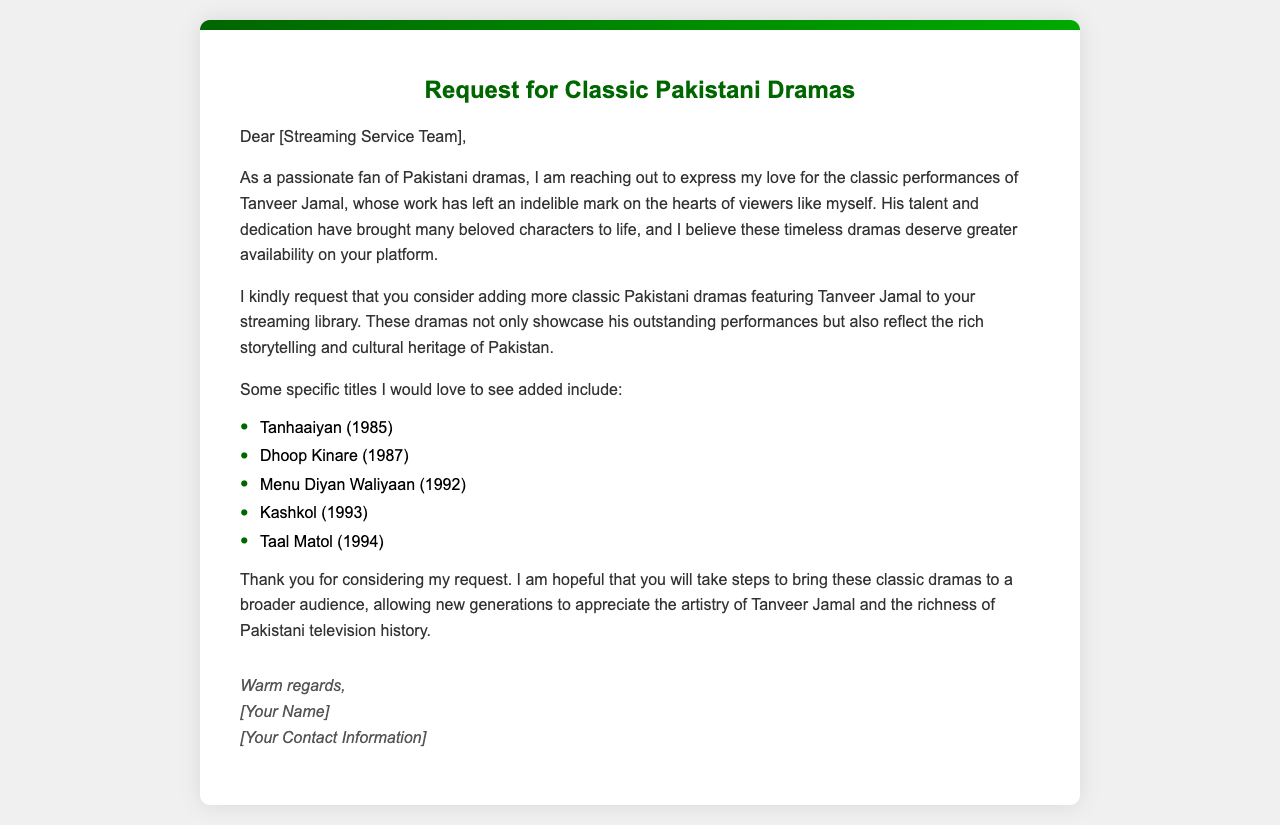What is the title of the letter? The title of the letter is prominently displayed at the top of the document, indicating the main purpose of the communication.
Answer: Request for Classic Pakistani Dramas Who is the letter addressed to? The greeting section of the letter indicates the recipient, suggesting it is directed towards the streaming service team.
Answer: Streaming Service Team In what year was 'Tanhaaiyan' released? The letter lists 'Tanhaaiyan' as one of the classic dramas and specifies its release date.
Answer: 1985 How many specific drama titles are mentioned in the letter? By counting the items listed in the specified section, we can determine the total number of dramas requested.
Answer: Five What is the main reason for the request in the letter? The letter elaborates on the request for classic dramas to be available due to the cultural significance and performances of Tanveer Jamal.
Answer: Greater availability Which performance of Tanveer Jamal is highlighted in the letter? The author mentions Tanveer Jamal's work and performances, particularly in regard to specific dramas that are suggested for addition.
Answer: Classic performances What kind of content is the letter requesting? The overall theme of the letter is focused on a specific type of content that showcases particular talents and cultural elements.
Answer: Classic Pakistani dramas What is the tone of the closing of the letter? The conclusion expresses gratitude while remaining hopeful about the potential response from the recipient.
Answer: Warm regards 